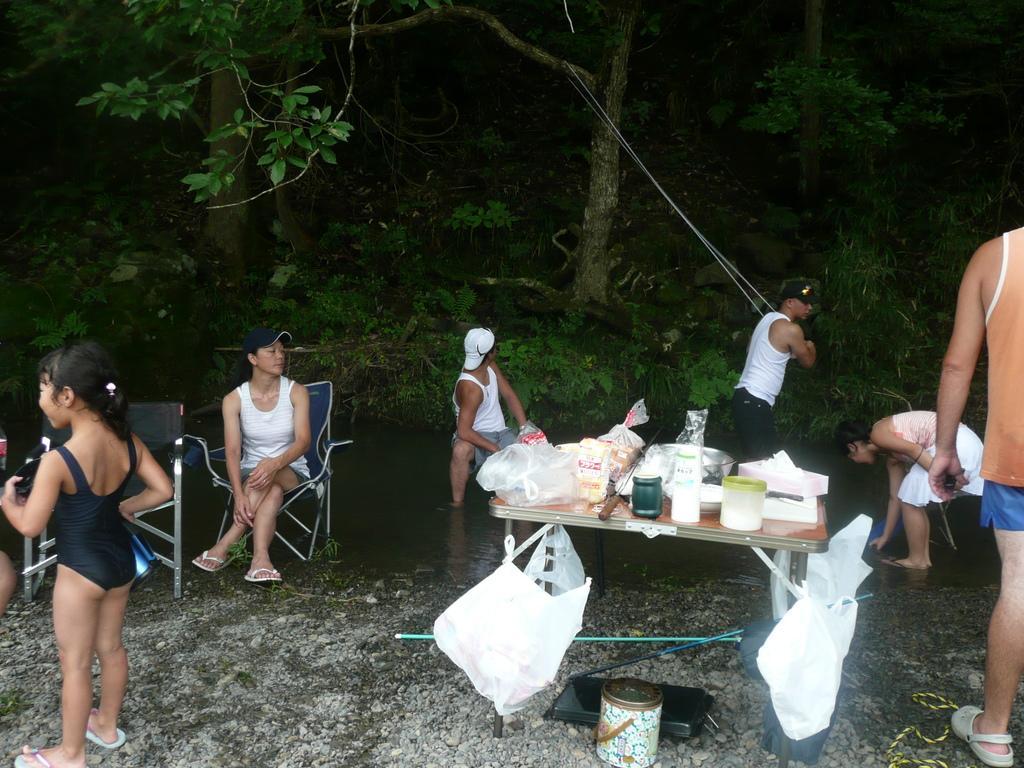Please provide a concise description of this image. In this image, we can see many people and some of them are sitting and there is a man holding a rope which is tied to a tree, we can see some jars and packets which are placed on the table and there are some bags also and we can see some objects on the ground. At the bottom, there is water. 